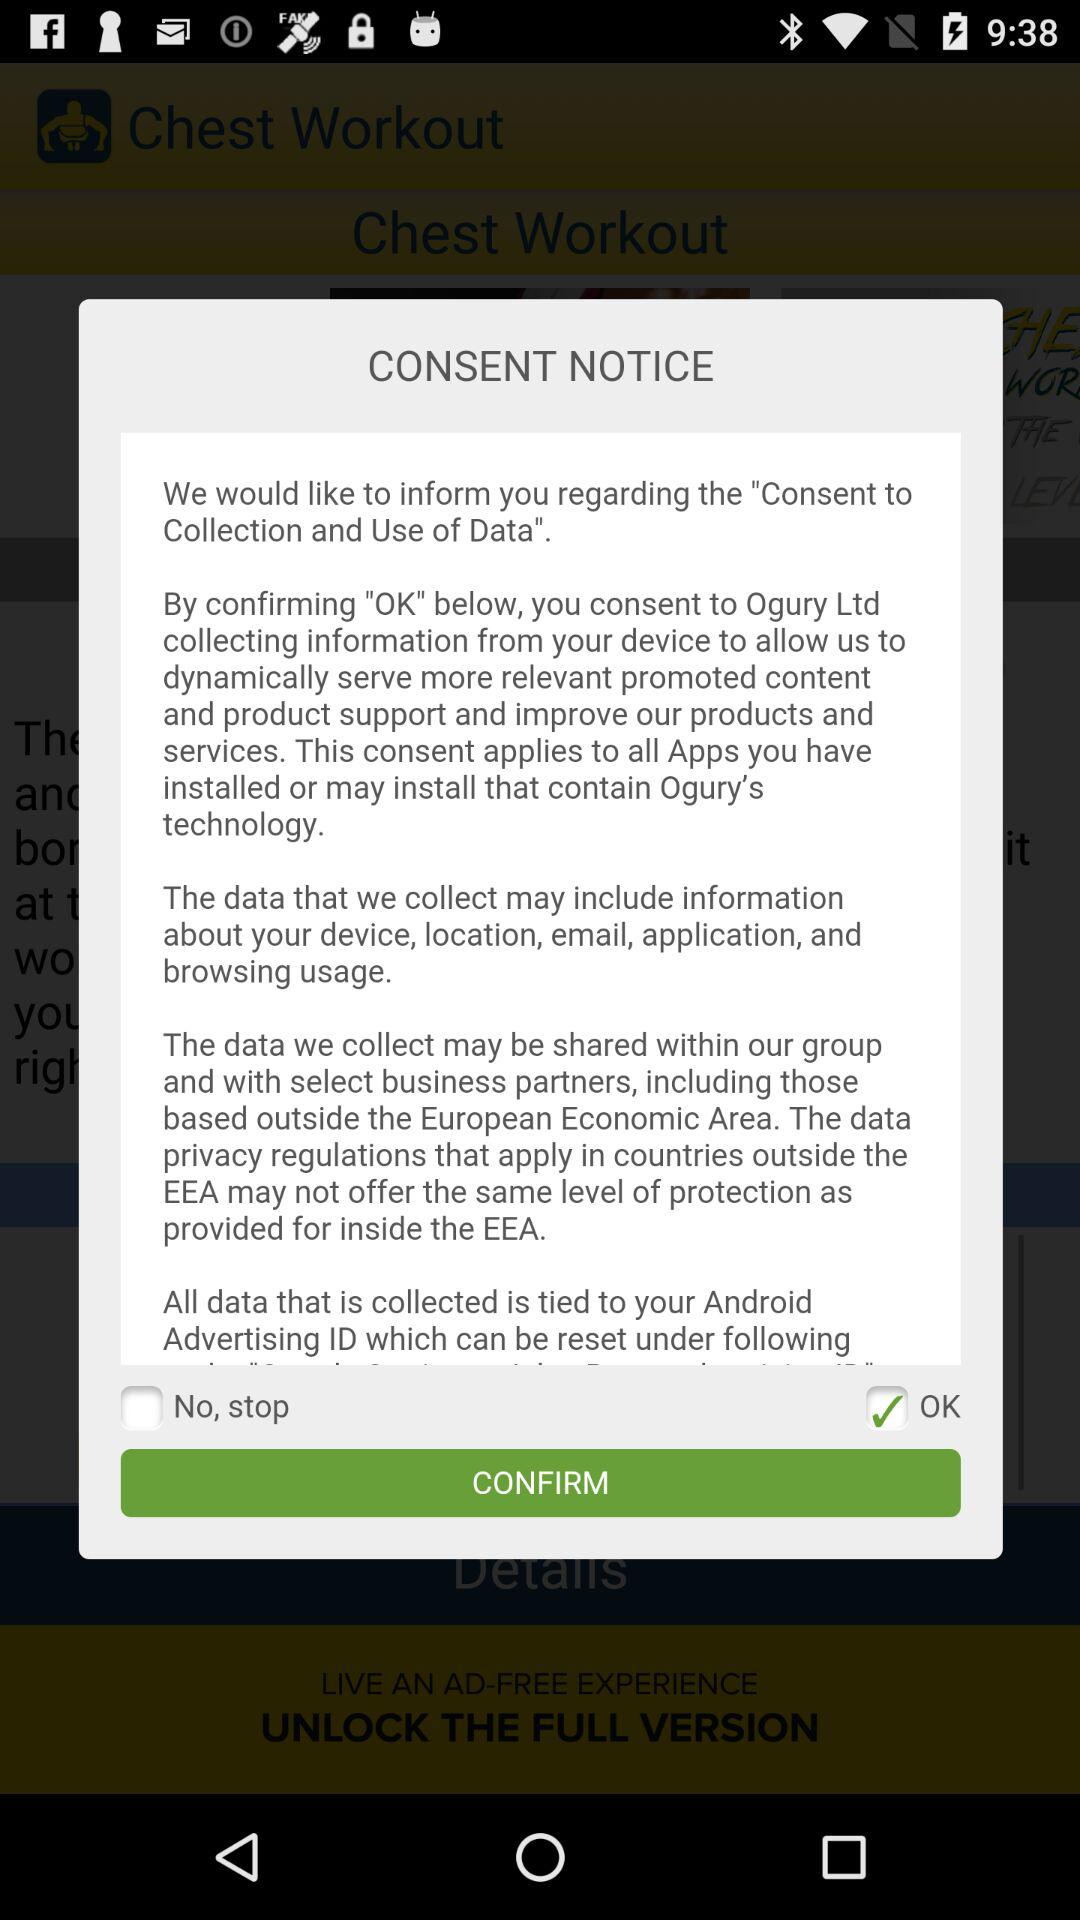How many checkboxes are on the screen?
Answer the question using a single word or phrase. 2 